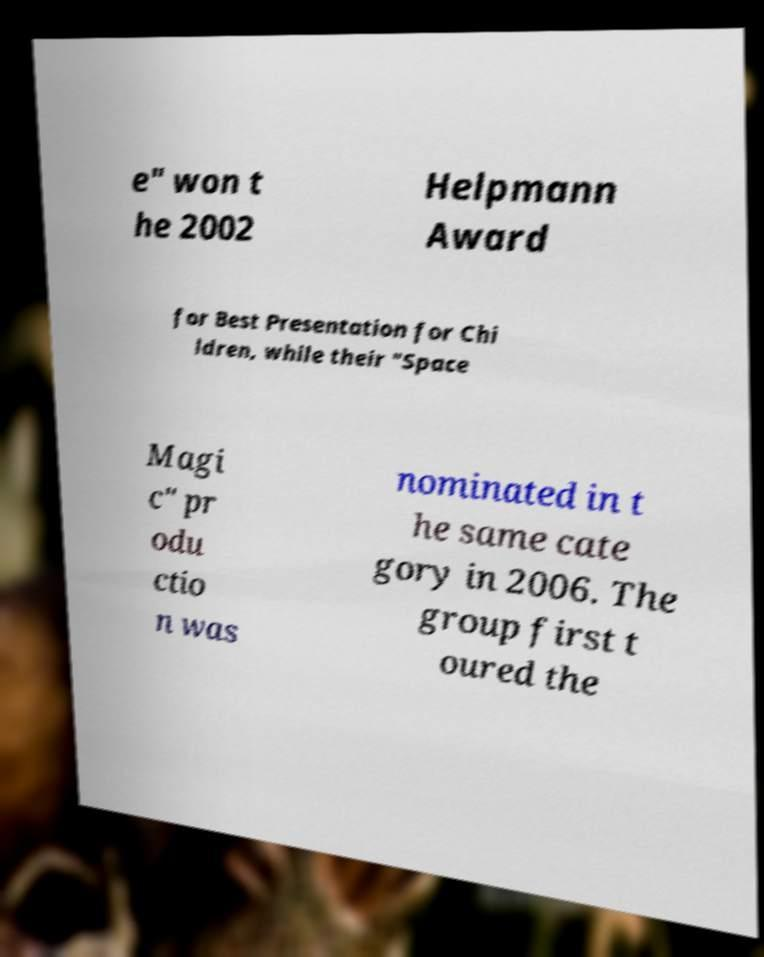I need the written content from this picture converted into text. Can you do that? e" won t he 2002 Helpmann Award for Best Presentation for Chi ldren, while their "Space Magi c" pr odu ctio n was nominated in t he same cate gory in 2006. The group first t oured the 